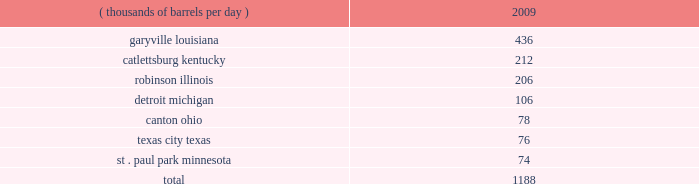Technical and research personnel and lab facilities , and significantly expanded the portfolio of patents available to us via license and through a cooperative development program .
In addition , we have acquired a 20 percent interest in grt , inc .
The gtftm technology is protected by an intellectual property protection program .
The u.s .
Has granted 17 patents for the technology , with another 22 pending .
Worldwide , there are over 300 patents issued or pending , covering over 100 countries including regional and direct foreign filings .
Another innovative technology that we are developing focuses on reducing the processing and transportation costs of natural gas by artificially creating natural gas hydrates , which are more easily transportable than natural gas in its gaseous form .
Much like lng , gas hydrates would then be regasified upon delivery to the receiving market .
We have an active pilot program in place to test and further develop a proprietary natural gas hydrates manufacturing system .
The above discussion of the integrated gas segment contains forward-looking statements with respect to the possible expansion of the lng production facility .
Factors that could potentially affect the possible expansion of the lng production facility include partner and government approvals , access to sufficient natural gas volumes through exploration or commercial negotiations with other resource owners and access to sufficient regasification capacity .
The foregoing factors ( among others ) could cause actual results to differ materially from those set forth in the forward-looking statements .
Refining , marketing and transportation we have refining , marketing and transportation operations concentrated primarily in the midwest , upper great plains , gulf coast and southeast regions of the u.s .
We rank as the fifth largest crude oil refiner in the u.s .
And the largest in the midwest .
Our operations include a seven-plant refining network and an integrated terminal and transportation system which supplies wholesale and marathon-brand customers as well as our own retail operations .
Our wholly-owned retail marketing subsidiary speedway superamerica llc ( 201cssa 201d ) is the third largest chain of company-owned and -operated retail gasoline and convenience stores in the u.s .
And the largest in the midwest .
Refining we own and operate seven refineries with an aggregate refining capacity of 1.188 million barrels per day ( 201cmmbpd 201d ) of crude oil as of december 31 , 2009 .
During 2009 , our refineries processed 957 mbpd of crude oil and 196 mbpd of other charge and blend stocks .
The table below sets forth the location and daily crude oil refining capacity of each of our refineries as of december 31 , 2009 .
Crude oil refining capacity ( thousands of barrels per day ) 2009 .
Our refineries include crude oil atmospheric and vacuum distillation , fluid catalytic cracking , catalytic reforming , desulfurization and sulfur recovery units .
The refineries process a wide variety of crude oils and produce numerous refined products , ranging from transportation fuels , such as reformulated gasolines , blend- grade gasolines intended for blending with fuel ethanol and ultra-low sulfur diesel fuel , to heavy fuel oil and asphalt .
Additionally , we manufacture aromatics , cumene , propane , propylene , sulfur and maleic anhydride .
Our garyville , louisiana , refinery is located along the mississippi river in southeastern louisiana between new orleans and baton rouge .
The garyville refinery predominantly processes heavy sour crude oil into products .
What percentage of crude oil refining capacity is located in catlettsburg kentucky? 
Computations: (212 / 1188)
Answer: 0.17845. 